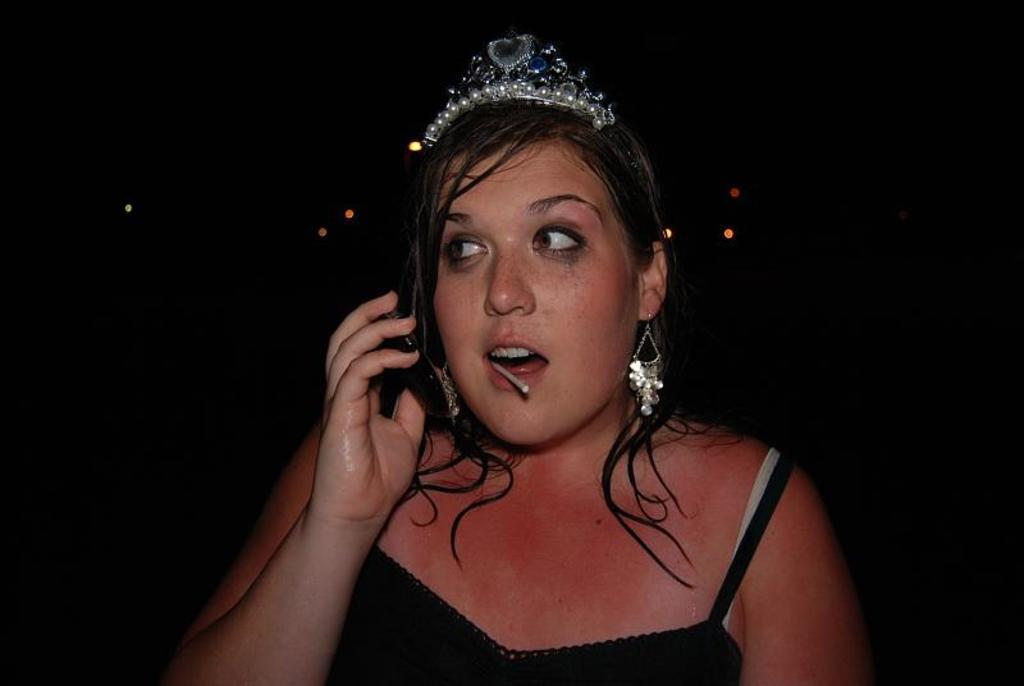Who is the main subject in the image? There is a woman in the image. What is the woman wearing? The woman is wearing a black dress and a crown. What is the color of the background in the image? The background of the image is black. What type of insurance does the woman have in the image? There is no information about insurance in the image; it only shows a woman wearing a black dress and a crown against a black background. 